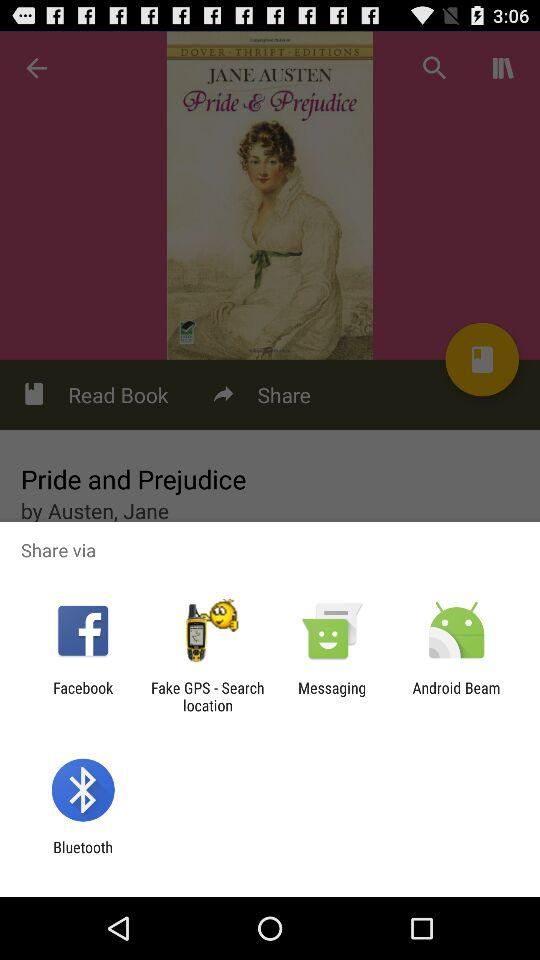What is the name of the application?
When the provided information is insufficient, respond with <no answer>. <no answer> 